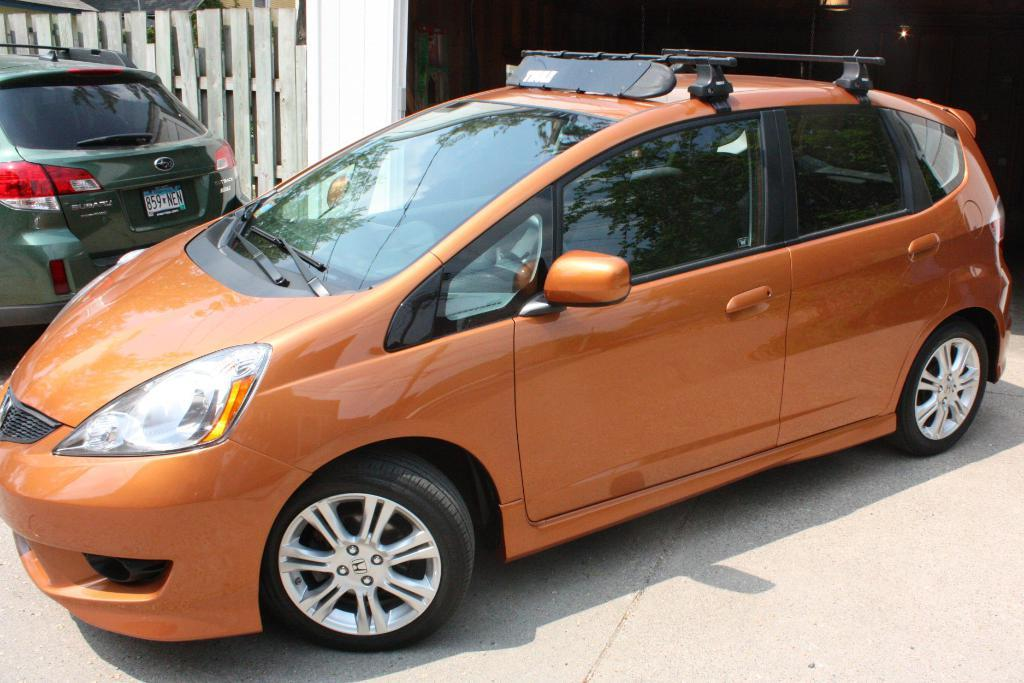What can be seen on the road in the image? There are cars on the road in the image. What is located behind the cars? There is a fence behind the cars. What can be seen in the distance in the image? There are lights visible in the background of the image. What type of animal can be seen interacting with the cars in the image? There is no animal present in the image; it only features cars on the road, a fence, and lights in the background. 